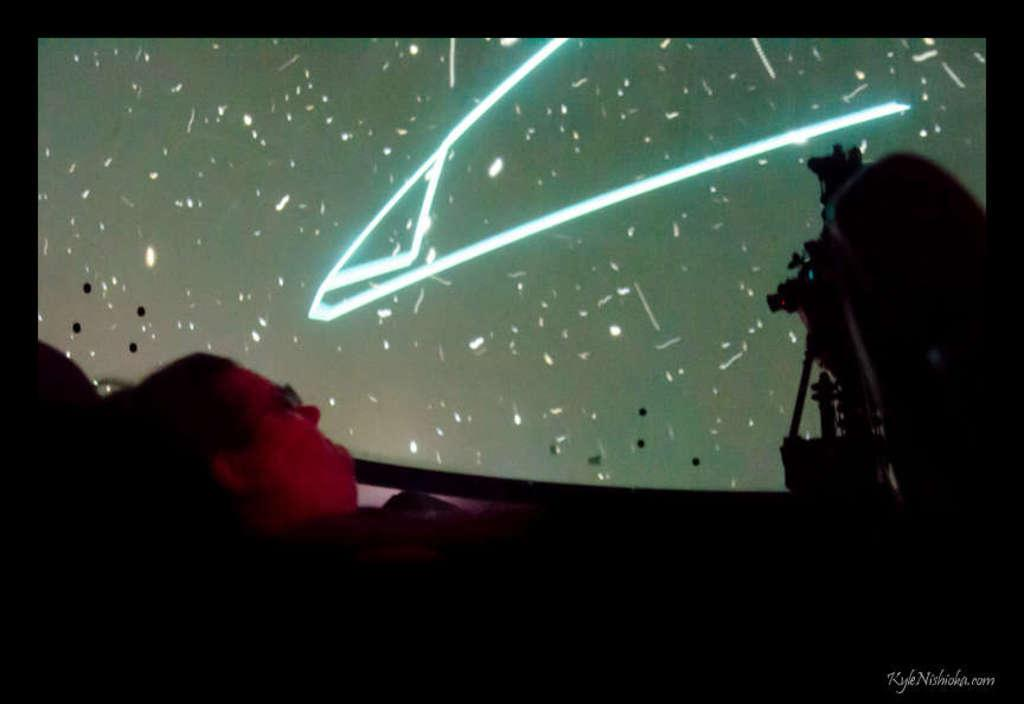What is the man in the image doing? The man is lying on the bed. What can be seen in the background of the image? There is a projector screen in the background. What object is on the right side of the image? There is a camera on the right side. What type of furniture is present in the image? There are chairs in the image. What type of love can be seen between the man and the camera in the image? There is no indication of love or any relationship between the man and the camera in the image. 